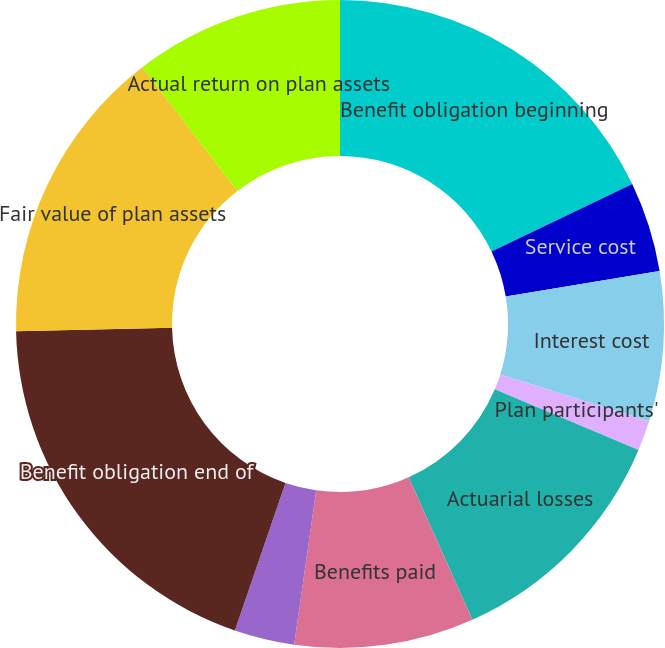Convert chart to OTSL. <chart><loc_0><loc_0><loc_500><loc_500><pie_chart><fcel>Benefit obligation beginning<fcel>Service cost<fcel>Interest cost<fcel>Plan participants'<fcel>Actuarial losses<fcel>Benefits paid<fcel>Foreign currency exchange rate<fcel>Benefit obligation end of<fcel>Fair value of plan assets<fcel>Actual return on plan assets<nl><fcel>17.89%<fcel>4.49%<fcel>7.47%<fcel>1.51%<fcel>11.94%<fcel>8.96%<fcel>3.0%<fcel>19.38%<fcel>14.91%<fcel>10.45%<nl></chart> 